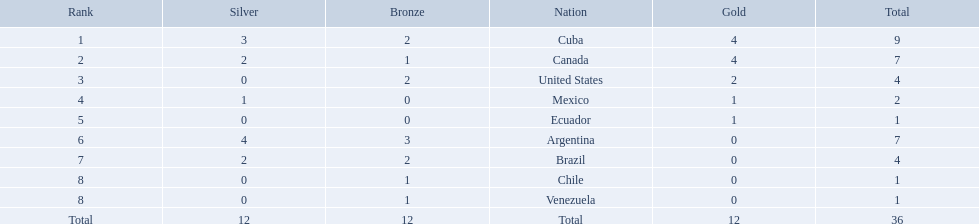Which countries won medals at the 2011 pan american games for the canoeing event? Cuba, Canada, United States, Mexico, Ecuador, Argentina, Brazil, Chile, Venezuela. Which of these countries won bronze medals? Cuba, Canada, United States, Argentina, Brazil, Chile, Venezuela. Of these countries, which won the most bronze medals? Argentina. 